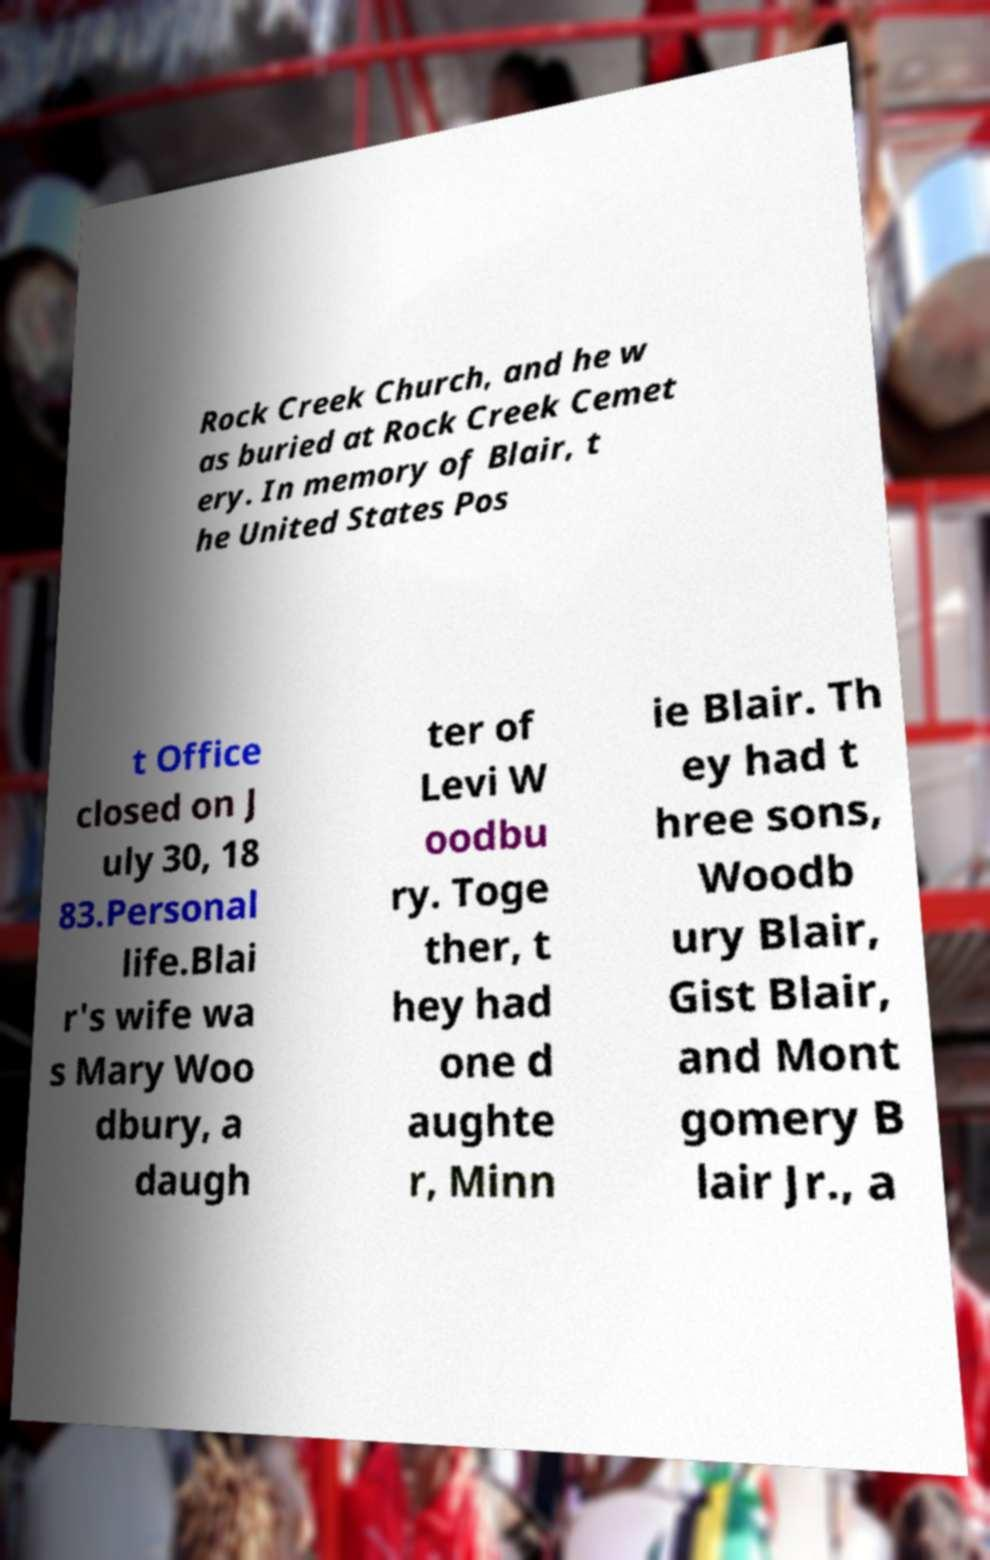For documentation purposes, I need the text within this image transcribed. Could you provide that? Rock Creek Church, and he w as buried at Rock Creek Cemet ery. In memory of Blair, t he United States Pos t Office closed on J uly 30, 18 83.Personal life.Blai r's wife wa s Mary Woo dbury, a daugh ter of Levi W oodbu ry. Toge ther, t hey had one d aughte r, Minn ie Blair. Th ey had t hree sons, Woodb ury Blair, Gist Blair, and Mont gomery B lair Jr., a 